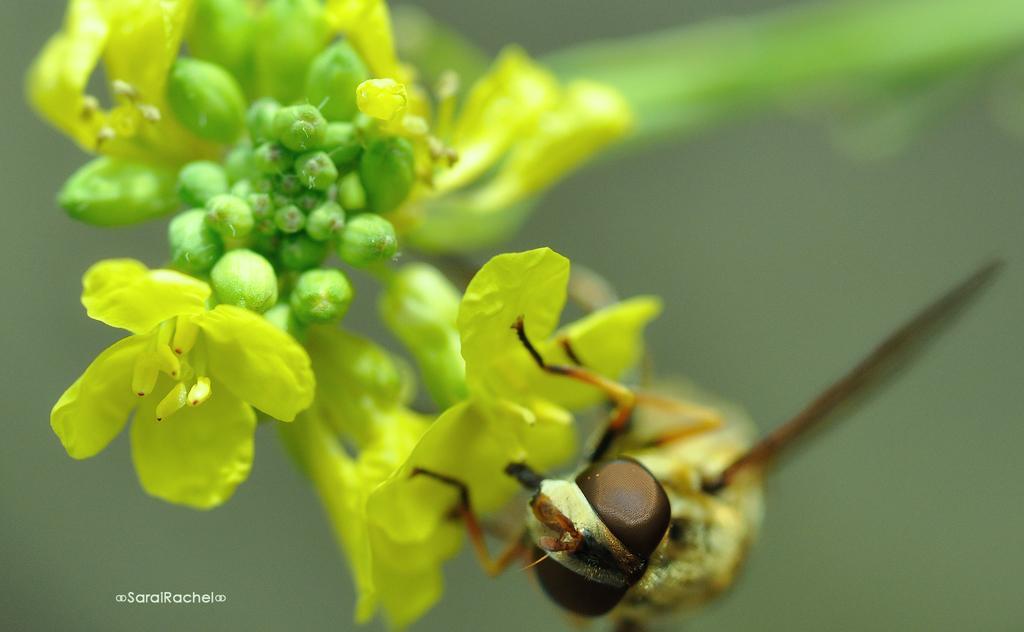How would you summarize this image in a sentence or two? In this image we can see an insect on the flower. We can also see the buds and the background is not clear. In the bottom left corner we can see the text. 